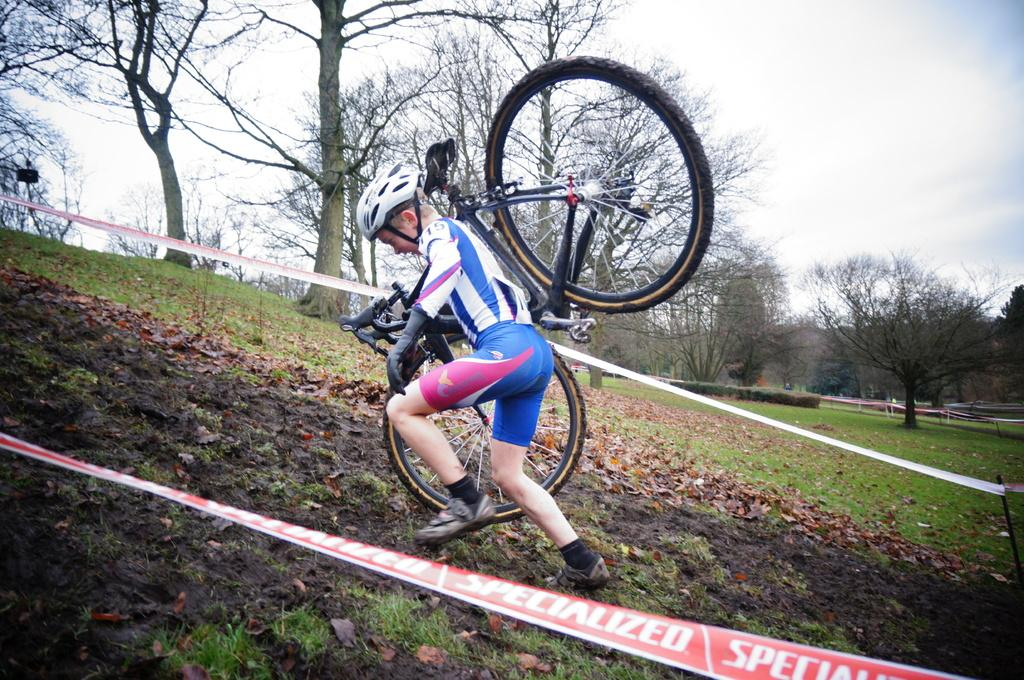Who is present in the image? There is a man in the image. What is the man doing in the image? The man is carrying a bicycle. What can be seen beside the man? There are ribbons beside the man. What type of natural environment is visible in the background of the image? There is grass, trees, and clouds visible in the background of the image. What type of credit can be seen on the man's shirt in the image? There is no credit or any text visible on the man's shirt in the image. How does the man stitch the bicycle together in the image? The man is not stitching the bicycle together in the image; he is simply carrying it. 